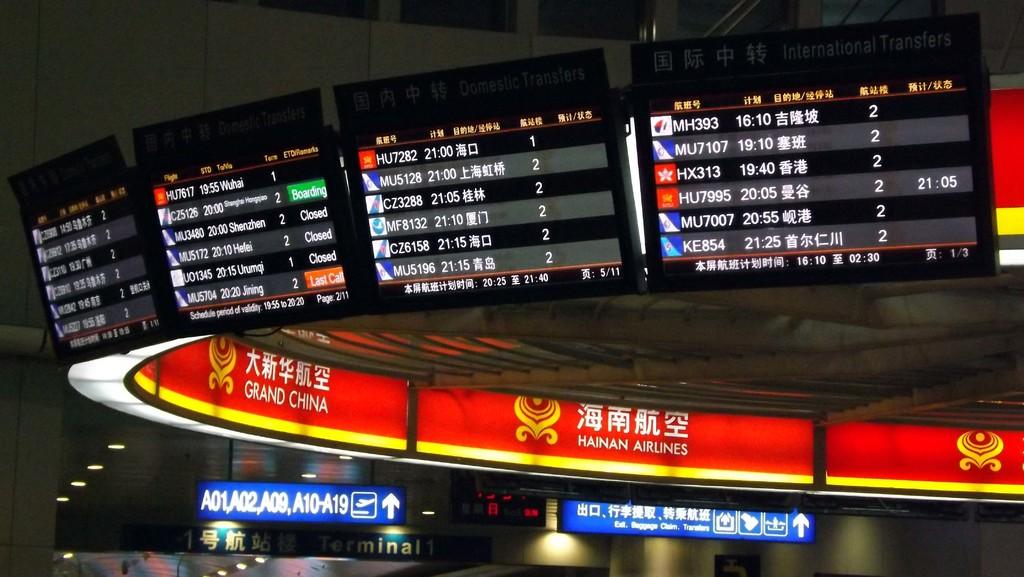Which airline is that?
Offer a terse response. Hainan airlines. What is the airlines on the red background?
Offer a very short reply. Hainan airlines. 